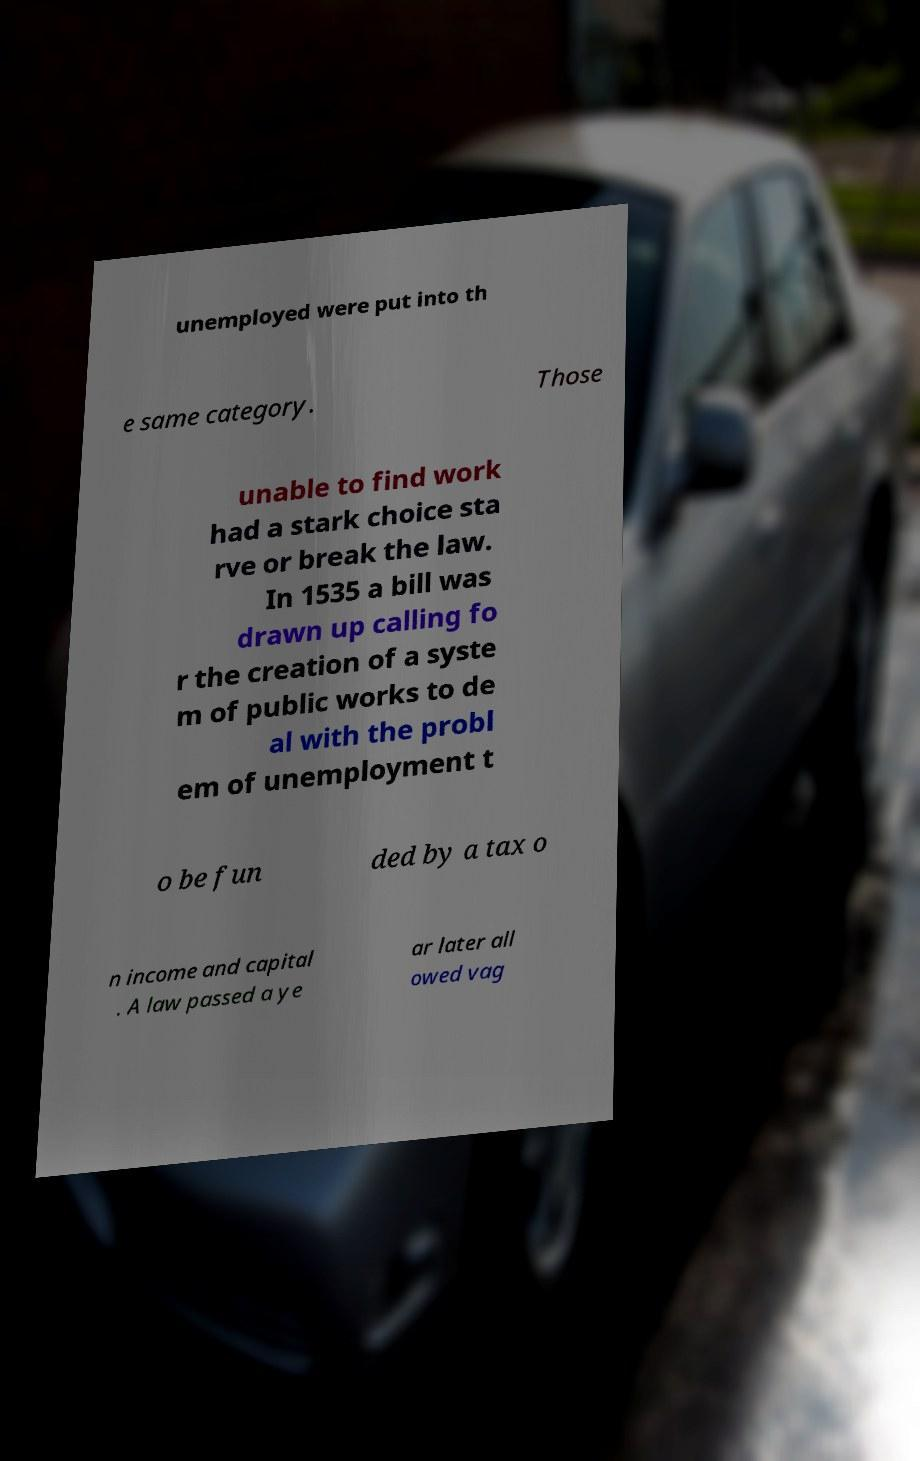What messages or text are displayed in this image? I need them in a readable, typed format. unemployed were put into th e same category. Those unable to find work had a stark choice sta rve or break the law. In 1535 a bill was drawn up calling fo r the creation of a syste m of public works to de al with the probl em of unemployment t o be fun ded by a tax o n income and capital . A law passed a ye ar later all owed vag 